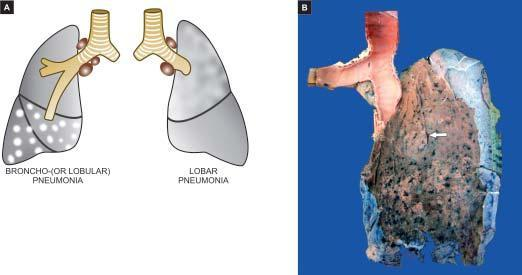what is spongy?
Answer the question using a single word or phrase. Intervening lung 